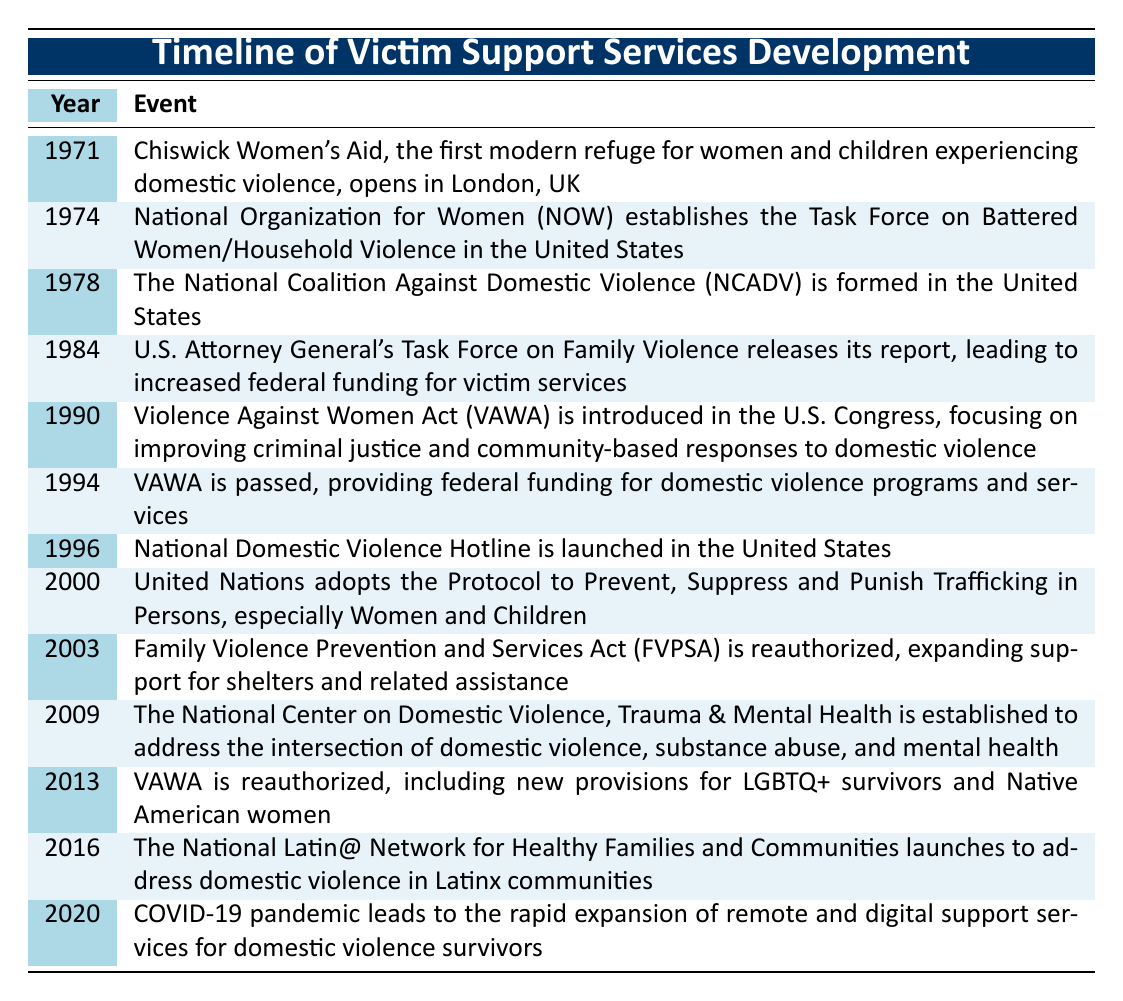What year did the first modern refuge for domestic violence open? The table indicates that Chiswick Women's Aid, the first modern refuge for women and children experiencing domestic violence, opened in 1971.
Answer: 1971 In which year was the Violence Against Women Act passed? According to the table, the Violence Against Women Act (VAWA) was passed in 1994, as listed under the events for that year.
Answer: 1994 Was the National Domestic Violence Hotline launched before or after 2000? The table shows that the National Domestic Violence Hotline was launched in 1996, which is before 2000.
Answer: Before How many key events occurred in the 1990s? The table shows a total of 6 key events listed for the 1990s: 1990, 1994, and 1996. Thus, the count is 3.
Answer: 3 What significant change occurred in 2013 regarding the Violence Against Women Act? The table indicates that in 2013, the VAWA was reauthorized, which included new provisions for LGBTQ+ survivors and Native American women. This indicates a significant expansion of its scope.
Answer: Reauthorization with new provisions Which event directly led to increased federal funding for victim services? The table states that the report from the U.S. Attorney General's Task Force on Family Violence released in 1984 led to increased federal funding for victim services, as noted in that year's event.
Answer: 1984 report How does the number of key events related to domestic violence in the 2000s compare to the 1990s? In the 1990s, there were 3 key events (1990, 1994, 1996), while in the 2000s, there are 4 key events (2000, 2003, 2009). To compare, we see an increase of 1 event in the 2000s compared to the 1990s.
Answer: 1 more event in the 2000s Did the COVID-19 pandemic contribute to changes in support services for domestic violence survivors? Yes, according to the table, the COVID-19 pandemic in 2020 led to the rapid expansion of remote and digital support services for domestic violence survivors, indicating a direct impact.
Answer: Yes What was the focus of the Family Violence Prevention and Services Act by 2003? The table indicates that in 2003, the Family Violence Prevention and Services Act (FVPSA) was reauthorized, expanding support for shelters and related assistance, reflecting a continued focus on enhancing resources for domestic violence survivors.
Answer: Expanded shelter support 